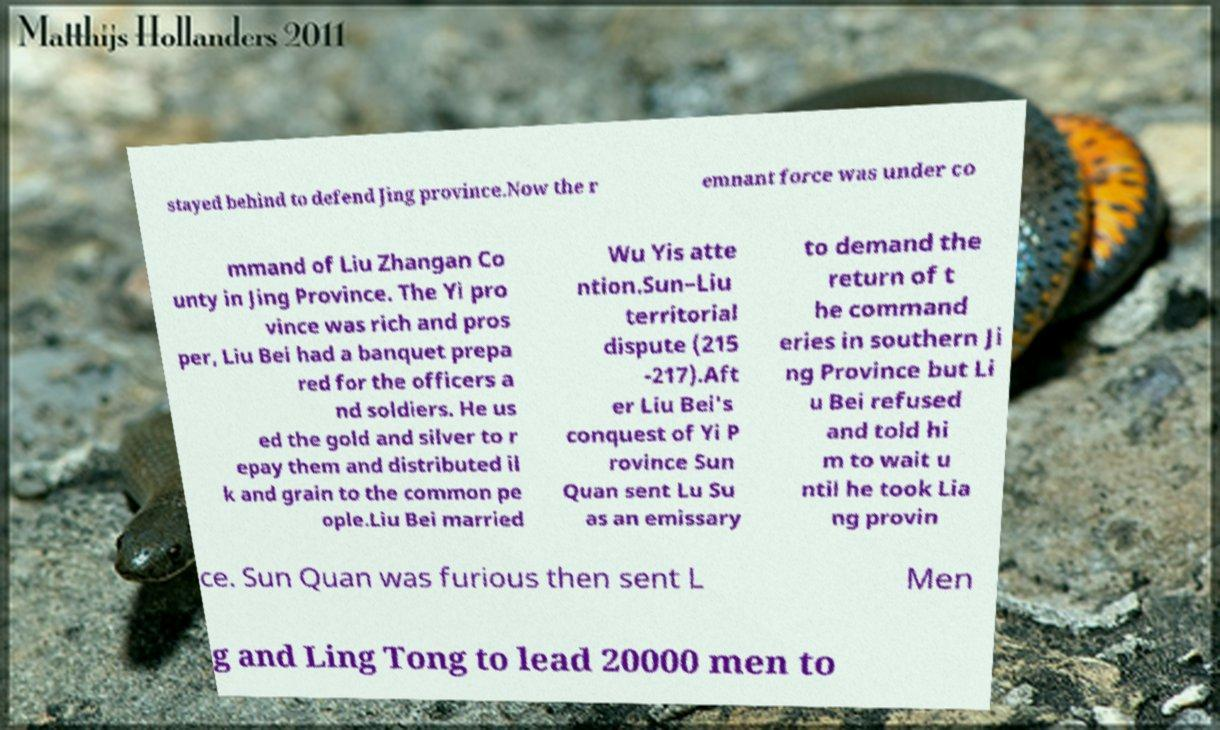What messages or text are displayed in this image? I need them in a readable, typed format. stayed behind to defend Jing province.Now the r emnant force was under co mmand of Liu Zhangan Co unty in Jing Province. The Yi pro vince was rich and pros per, Liu Bei had a banquet prepa red for the officers a nd soldiers. He us ed the gold and silver to r epay them and distributed il k and grain to the common pe ople.Liu Bei married Wu Yis atte ntion.Sun–Liu territorial dispute (215 -217).Aft er Liu Bei's conquest of Yi P rovince Sun Quan sent Lu Su as an emissary to demand the return of t he command eries in southern Ji ng Province but Li u Bei refused and told hi m to wait u ntil he took Lia ng provin ce. Sun Quan was furious then sent L Men g and Ling Tong to lead 20000 men to 